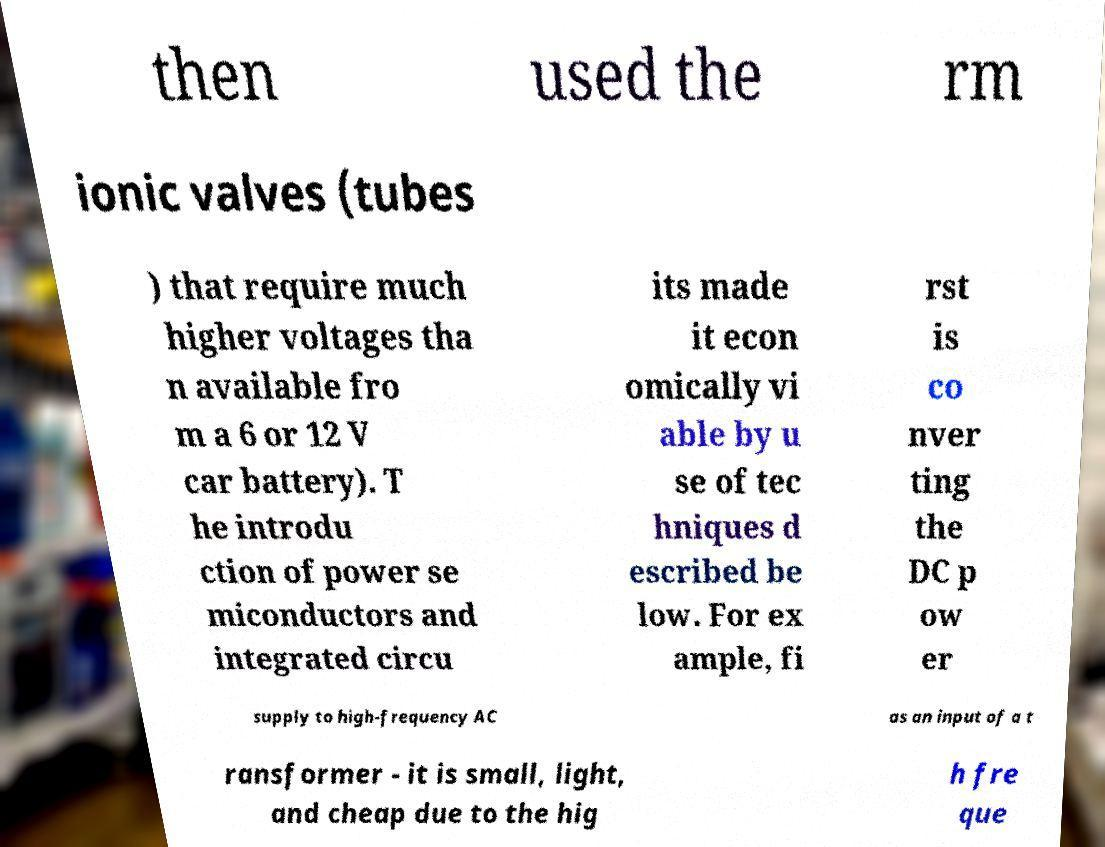Please identify and transcribe the text found in this image. then used the rm ionic valves (tubes ) that require much higher voltages tha n available fro m a 6 or 12 V car battery). T he introdu ction of power se miconductors and integrated circu its made it econ omically vi able by u se of tec hniques d escribed be low. For ex ample, fi rst is co nver ting the DC p ow er supply to high-frequency AC as an input of a t ransformer - it is small, light, and cheap due to the hig h fre que 